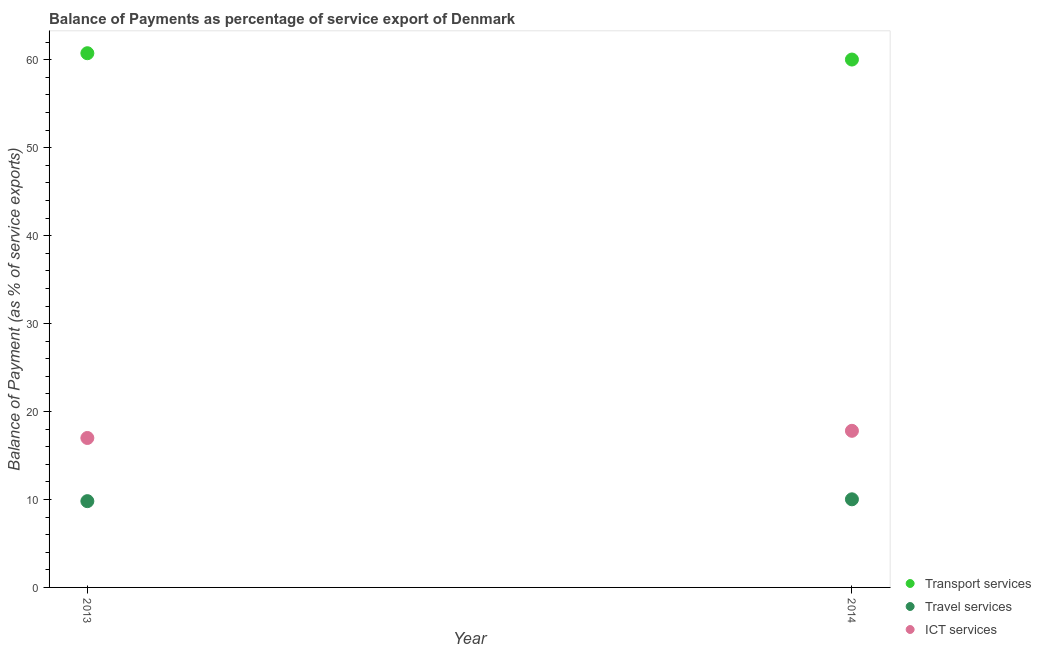What is the balance of payment of transport services in 2014?
Offer a terse response. 60.03. Across all years, what is the maximum balance of payment of ict services?
Keep it short and to the point. 17.81. Across all years, what is the minimum balance of payment of travel services?
Provide a short and direct response. 9.81. What is the total balance of payment of ict services in the graph?
Keep it short and to the point. 34.8. What is the difference between the balance of payment of ict services in 2013 and that in 2014?
Give a very brief answer. -0.81. What is the difference between the balance of payment of ict services in 2014 and the balance of payment of travel services in 2013?
Ensure brevity in your answer.  8. What is the average balance of payment of ict services per year?
Provide a short and direct response. 17.4. In the year 2013, what is the difference between the balance of payment of transport services and balance of payment of travel services?
Provide a short and direct response. 50.94. In how many years, is the balance of payment of transport services greater than 6 %?
Your response must be concise. 2. What is the ratio of the balance of payment of travel services in 2013 to that in 2014?
Offer a very short reply. 0.98. In how many years, is the balance of payment of travel services greater than the average balance of payment of travel services taken over all years?
Give a very brief answer. 1. Does the balance of payment of ict services monotonically increase over the years?
Keep it short and to the point. Yes. Is the balance of payment of ict services strictly greater than the balance of payment of transport services over the years?
Your answer should be very brief. No. Is the balance of payment of transport services strictly less than the balance of payment of ict services over the years?
Your response must be concise. No. How many years are there in the graph?
Your response must be concise. 2. What is the difference between two consecutive major ticks on the Y-axis?
Give a very brief answer. 10. Does the graph contain grids?
Give a very brief answer. No. How are the legend labels stacked?
Provide a short and direct response. Vertical. What is the title of the graph?
Your answer should be compact. Balance of Payments as percentage of service export of Denmark. Does "Ages 20-50" appear as one of the legend labels in the graph?
Keep it short and to the point. No. What is the label or title of the Y-axis?
Ensure brevity in your answer.  Balance of Payment (as % of service exports). What is the Balance of Payment (as % of service exports) of Transport services in 2013?
Your answer should be very brief. 60.75. What is the Balance of Payment (as % of service exports) of Travel services in 2013?
Provide a succinct answer. 9.81. What is the Balance of Payment (as % of service exports) of ICT services in 2013?
Ensure brevity in your answer.  16.99. What is the Balance of Payment (as % of service exports) of Transport services in 2014?
Offer a very short reply. 60.03. What is the Balance of Payment (as % of service exports) in Travel services in 2014?
Your response must be concise. 10.02. What is the Balance of Payment (as % of service exports) of ICT services in 2014?
Ensure brevity in your answer.  17.81. Across all years, what is the maximum Balance of Payment (as % of service exports) of Transport services?
Ensure brevity in your answer.  60.75. Across all years, what is the maximum Balance of Payment (as % of service exports) in Travel services?
Provide a succinct answer. 10.02. Across all years, what is the maximum Balance of Payment (as % of service exports) of ICT services?
Offer a terse response. 17.81. Across all years, what is the minimum Balance of Payment (as % of service exports) in Transport services?
Ensure brevity in your answer.  60.03. Across all years, what is the minimum Balance of Payment (as % of service exports) of Travel services?
Make the answer very short. 9.81. Across all years, what is the minimum Balance of Payment (as % of service exports) in ICT services?
Your answer should be compact. 16.99. What is the total Balance of Payment (as % of service exports) in Transport services in the graph?
Keep it short and to the point. 120.78. What is the total Balance of Payment (as % of service exports) in Travel services in the graph?
Keep it short and to the point. 19.83. What is the total Balance of Payment (as % of service exports) of ICT services in the graph?
Offer a very short reply. 34.8. What is the difference between the Balance of Payment (as % of service exports) of Transport services in 2013 and that in 2014?
Provide a short and direct response. 0.72. What is the difference between the Balance of Payment (as % of service exports) of Travel services in 2013 and that in 2014?
Ensure brevity in your answer.  -0.21. What is the difference between the Balance of Payment (as % of service exports) of ICT services in 2013 and that in 2014?
Keep it short and to the point. -0.81. What is the difference between the Balance of Payment (as % of service exports) in Transport services in 2013 and the Balance of Payment (as % of service exports) in Travel services in 2014?
Provide a short and direct response. 50.73. What is the difference between the Balance of Payment (as % of service exports) of Transport services in 2013 and the Balance of Payment (as % of service exports) of ICT services in 2014?
Offer a very short reply. 42.94. What is the difference between the Balance of Payment (as % of service exports) of Travel services in 2013 and the Balance of Payment (as % of service exports) of ICT services in 2014?
Provide a short and direct response. -8. What is the average Balance of Payment (as % of service exports) of Transport services per year?
Your answer should be very brief. 60.39. What is the average Balance of Payment (as % of service exports) of Travel services per year?
Give a very brief answer. 9.92. What is the average Balance of Payment (as % of service exports) in ICT services per year?
Provide a short and direct response. 17.4. In the year 2013, what is the difference between the Balance of Payment (as % of service exports) of Transport services and Balance of Payment (as % of service exports) of Travel services?
Ensure brevity in your answer.  50.94. In the year 2013, what is the difference between the Balance of Payment (as % of service exports) of Transport services and Balance of Payment (as % of service exports) of ICT services?
Your response must be concise. 43.75. In the year 2013, what is the difference between the Balance of Payment (as % of service exports) in Travel services and Balance of Payment (as % of service exports) in ICT services?
Offer a terse response. -7.18. In the year 2014, what is the difference between the Balance of Payment (as % of service exports) in Transport services and Balance of Payment (as % of service exports) in Travel services?
Ensure brevity in your answer.  50.01. In the year 2014, what is the difference between the Balance of Payment (as % of service exports) in Transport services and Balance of Payment (as % of service exports) in ICT services?
Your answer should be very brief. 42.22. In the year 2014, what is the difference between the Balance of Payment (as % of service exports) in Travel services and Balance of Payment (as % of service exports) in ICT services?
Make the answer very short. -7.79. What is the ratio of the Balance of Payment (as % of service exports) of Transport services in 2013 to that in 2014?
Provide a short and direct response. 1.01. What is the ratio of the Balance of Payment (as % of service exports) in Travel services in 2013 to that in 2014?
Your answer should be compact. 0.98. What is the ratio of the Balance of Payment (as % of service exports) of ICT services in 2013 to that in 2014?
Provide a succinct answer. 0.95. What is the difference between the highest and the second highest Balance of Payment (as % of service exports) of Transport services?
Provide a short and direct response. 0.72. What is the difference between the highest and the second highest Balance of Payment (as % of service exports) of Travel services?
Keep it short and to the point. 0.21. What is the difference between the highest and the second highest Balance of Payment (as % of service exports) in ICT services?
Ensure brevity in your answer.  0.81. What is the difference between the highest and the lowest Balance of Payment (as % of service exports) of Transport services?
Your answer should be very brief. 0.72. What is the difference between the highest and the lowest Balance of Payment (as % of service exports) in Travel services?
Offer a terse response. 0.21. What is the difference between the highest and the lowest Balance of Payment (as % of service exports) in ICT services?
Make the answer very short. 0.81. 